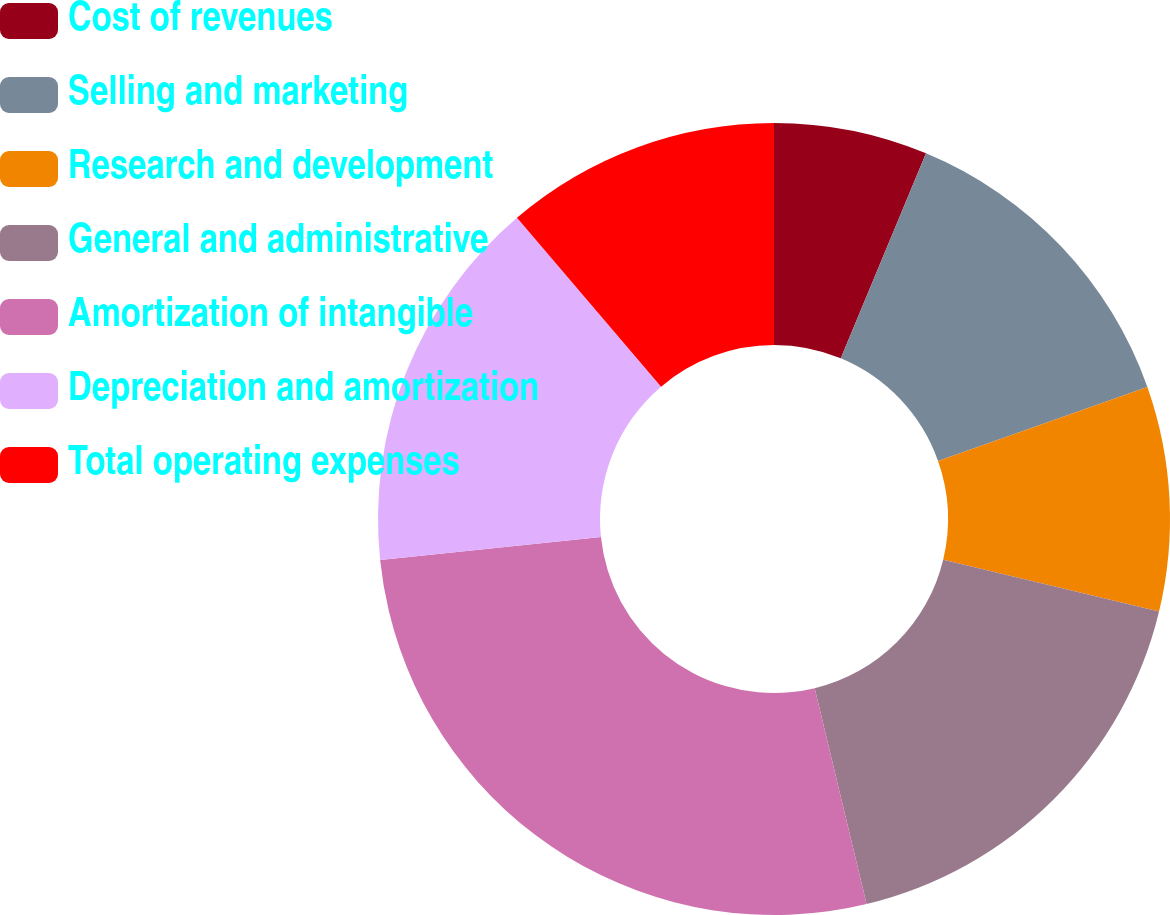Convert chart to OTSL. <chart><loc_0><loc_0><loc_500><loc_500><pie_chart><fcel>Cost of revenues<fcel>Selling and marketing<fcel>Research and development<fcel>General and administrative<fcel>Amortization of intangible<fcel>Depreciation and amortization<fcel>Total operating expenses<nl><fcel>6.27%<fcel>13.32%<fcel>9.16%<fcel>17.49%<fcel>27.1%<fcel>15.41%<fcel>11.24%<nl></chart> 